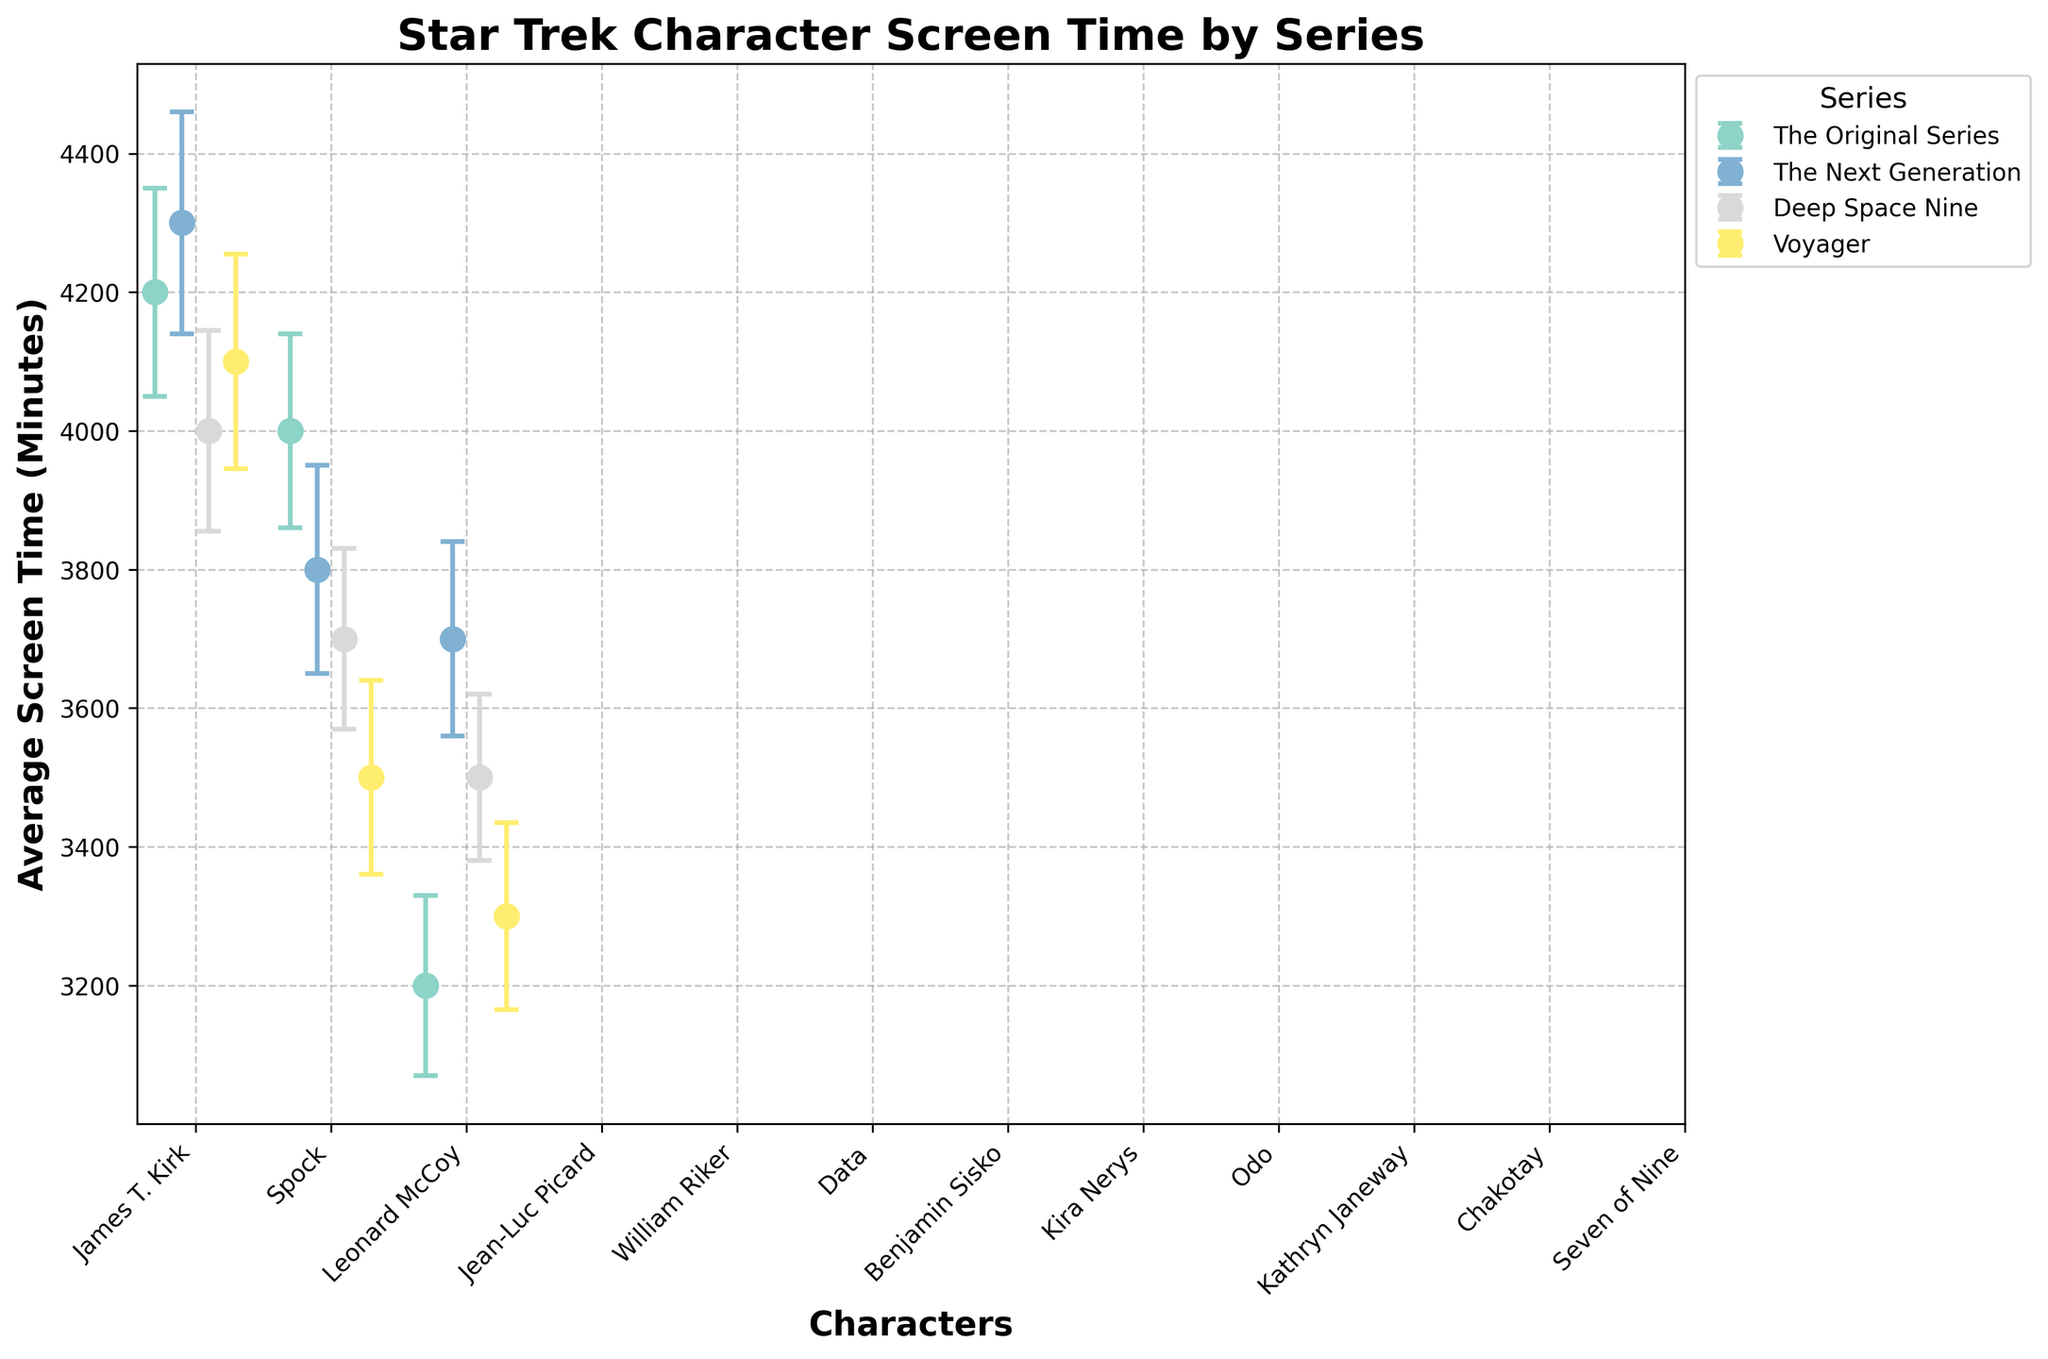Which series has the character with the highest average screen time? From the plot, locate the highest point on the y-axis. The highest average screen time is for Jean-Luc Picard in "The Next Generation" with 4300 minutes.
Answer: The Next Generation How much more average screen time does James T. Kirk have compared to Leonard McCoy? We need to find the difference between James T. Kirk's and Leonard McCoy's screen times in "The Original Series". Subtract McCoy's screen time (3200) from Kirk's (4200): 4200 - 3200 = 1000 minutes.
Answer: 1000 minutes Which character from Deep Space Nine has the highest average screen time, and what is that time? Look at the data points for Deep Space Nine and identify the highest one. Benjamin Sisko has the highest screen time, which is 4000 minutes.
Answer: Benjamin Sisko, 4000 minutes Between Kathryn Janeway and Benjamin Sisko, who has a higher average screen time and by how much? Compare the screen times of Kathryn Janeway (4100) and Benjamin Sisko (4000). Janeway has more, and the difference is 4100 - 4000 = 100 minutes.
Answer: Kathryn Janeway, 100 minutes What are the standard deviations for William Riker and Data? From the plot, locate William Riker's and Data's error bars in "The Next Generation." William Riker has a standard deviation of 150, and Data has 140.
Answer: William Riker: 150, Data: 140 What is the total combined average screen time of all characters in The Original Series? Sum the average screen times of James T. Kirk (4200), Spock (4000), and Leonard McCoy (3200). The total is 4200 + 4000 + 3200 = 11400 minutes.
Answer: 11400 minutes Which character has the smallest standard deviation in their screen time? Locate the smallest error bar in the plot. Odo from Deep Space Nine has the smallest standard deviation, which is 120.
Answer: Odo Compare the average screen times of Kira Nerys and Seven of Nine. Identify Kira Nerys's screen time (3700) in Deep Space Nine and Seven of Nine's (3300) in Voyager. Kira Nerys has more screen time than Seven of Nine.
Answer: Kira Nerys What is the average screen time of characters in Voyager? Add the average screen times of Kathryn Janeway (4100), Chakotay (3500), and Seven of Nine (3300) and divide by 3. (4100 + 3500 + 3300) / 3 = 10900 / 3 = 3633.33 minutes.
Answer: 3633.33 minutes Which series exhibits the greatest variability in screen time among its characters? Look for the series with the largest average standard deviation. Calculate: 
The Original Series: (150 + 140 + 130) / 3 = 140 
The Next Generation: (160 + 150 + 140) / 3 = 150 
Deep Space Nine: (145 + 130 + 120) / 3 = 131.67 
Voyager: (155 + 140 + 135) / 3 = 143.33 
The Next Generation has the highest variability with an average standard deviation of 150.
Answer: The Next Generation 